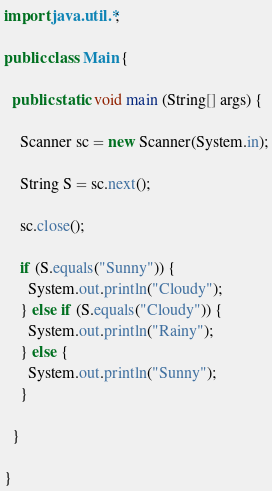Convert code to text. <code><loc_0><loc_0><loc_500><loc_500><_Java_>import java.util.*;

public class Main {

  public static void main (String[] args) {

    Scanner sc = new Scanner(System.in);

    String S = sc.next();

    sc.close();

    if (S.equals("Sunny")) {
      System.out.println("Cloudy");
    } else if (S.equals("Cloudy")) {
      System.out.println("Rainy");
    } else {
      System.out.println("Sunny");
    }

  }

}</code> 